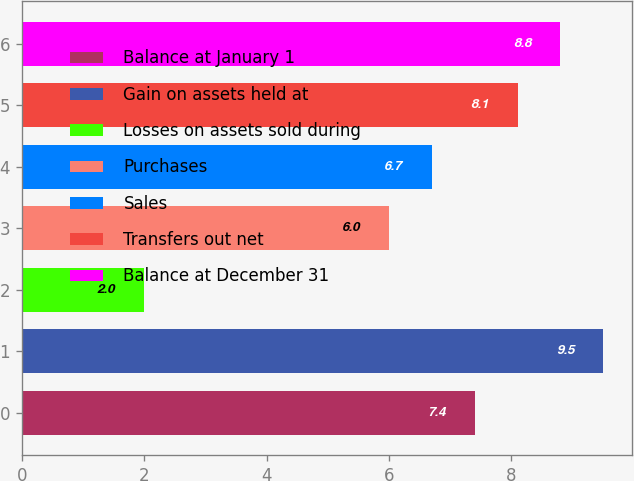Convert chart to OTSL. <chart><loc_0><loc_0><loc_500><loc_500><bar_chart><fcel>Balance at January 1<fcel>Gain on assets held at<fcel>Losses on assets sold during<fcel>Purchases<fcel>Sales<fcel>Transfers out net<fcel>Balance at December 31<nl><fcel>7.4<fcel>9.5<fcel>2<fcel>6<fcel>6.7<fcel>8.1<fcel>8.8<nl></chart> 